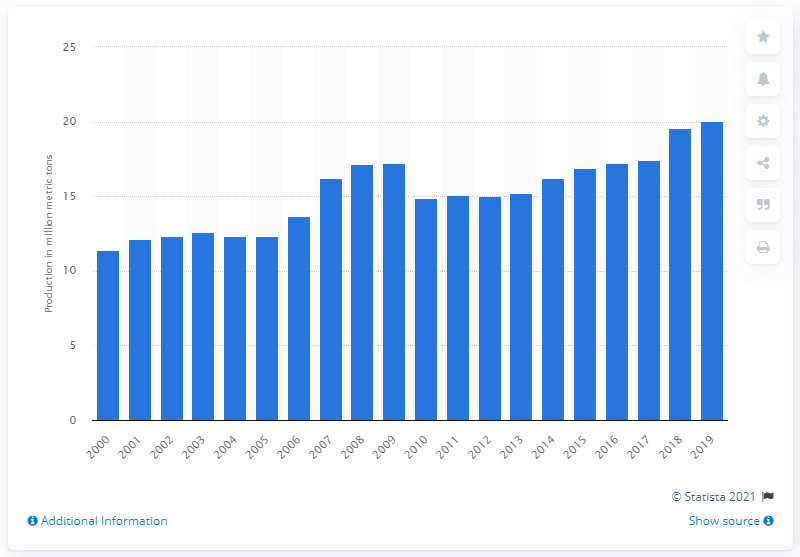Specify some key components in this picture. In the previous year, the production of lemons and limes was 19.58. In 2019, the global production of lemons and limes was 20.05 million metric tons. 